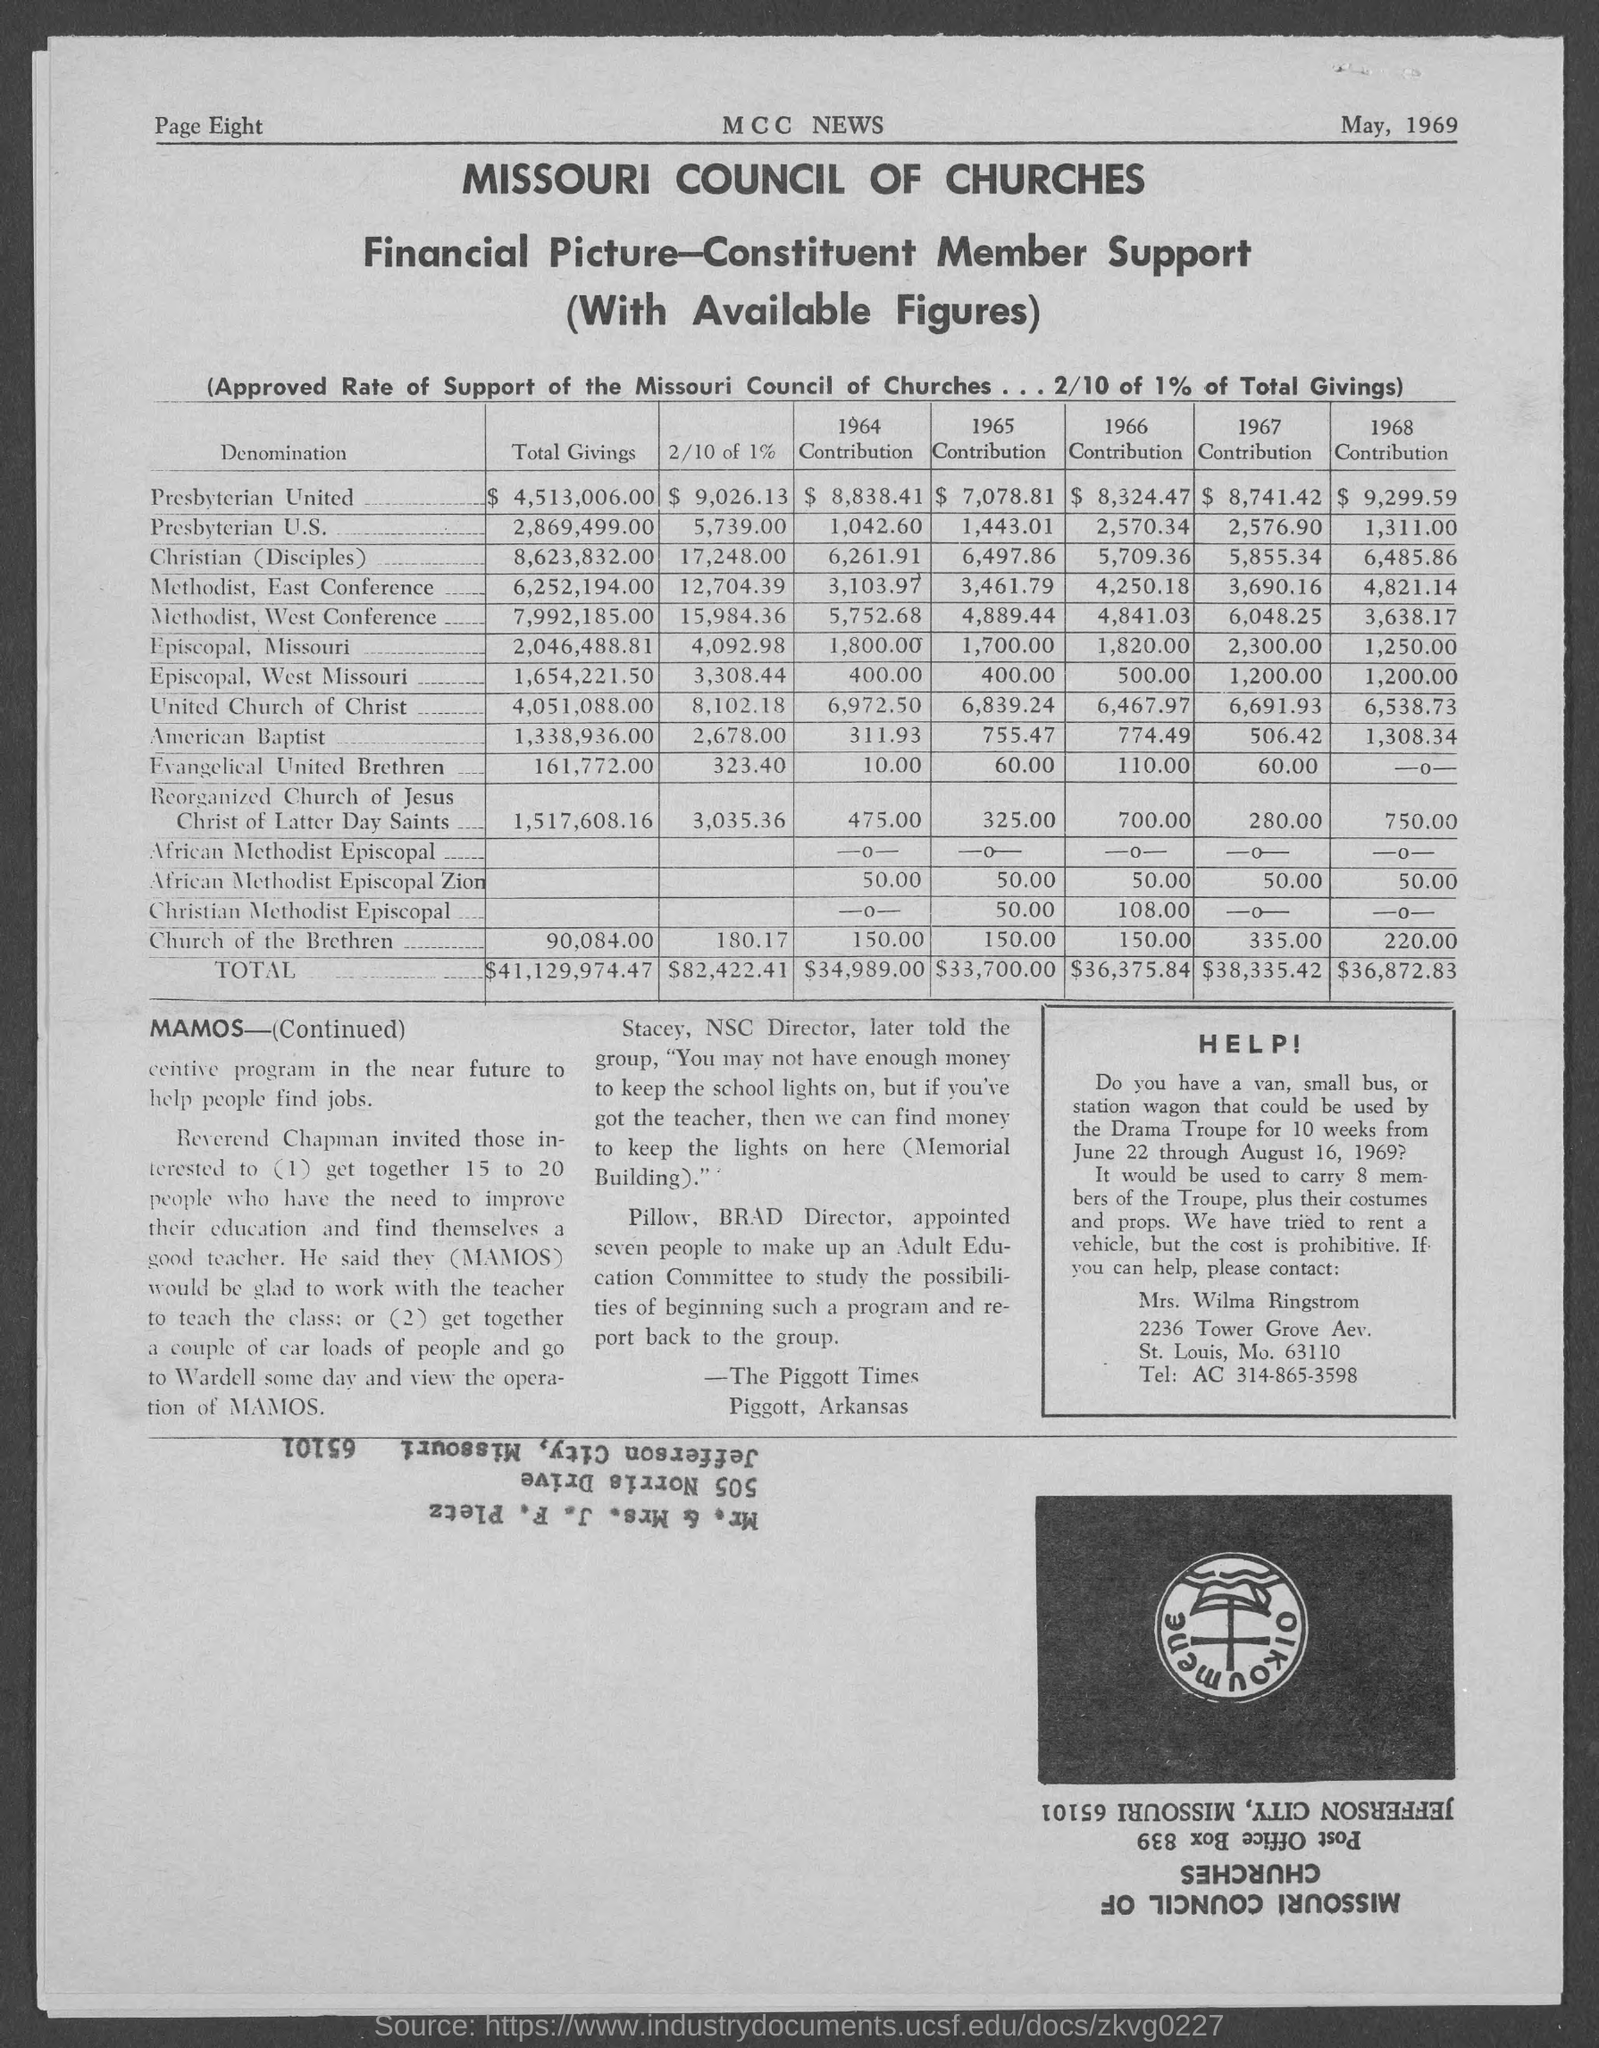What is the Title of the document?
Your response must be concise. Missouri council of churches. What is the date on the document?
Your response must be concise. May, 1969. What are the Total Givings for Pesbyterian United?
Your answer should be very brief. $4,513,006.00. What are the Total Givings for Pesbyterian U.S.?
Your response must be concise. 2,869,499.00. What are the Total Givings for Christian Disciples?
Your response must be concise. 8,623,832.00. What are the Total Givings for Methodist, East Conference?
Your answer should be very brief. 6,252,194.00. What are the Total Givings for Methodist, West Conference?
Make the answer very short. 7,992,185.00. What are the Total Givings for Episcopal, Missouri?
Keep it short and to the point. 2,046,488.81. What are the Total Givings for Episcopal, West Missouri?
Ensure brevity in your answer.  1,654,221.50. What are the Total Givings for American Baptist?
Your answer should be compact. `1,338,936.00. 